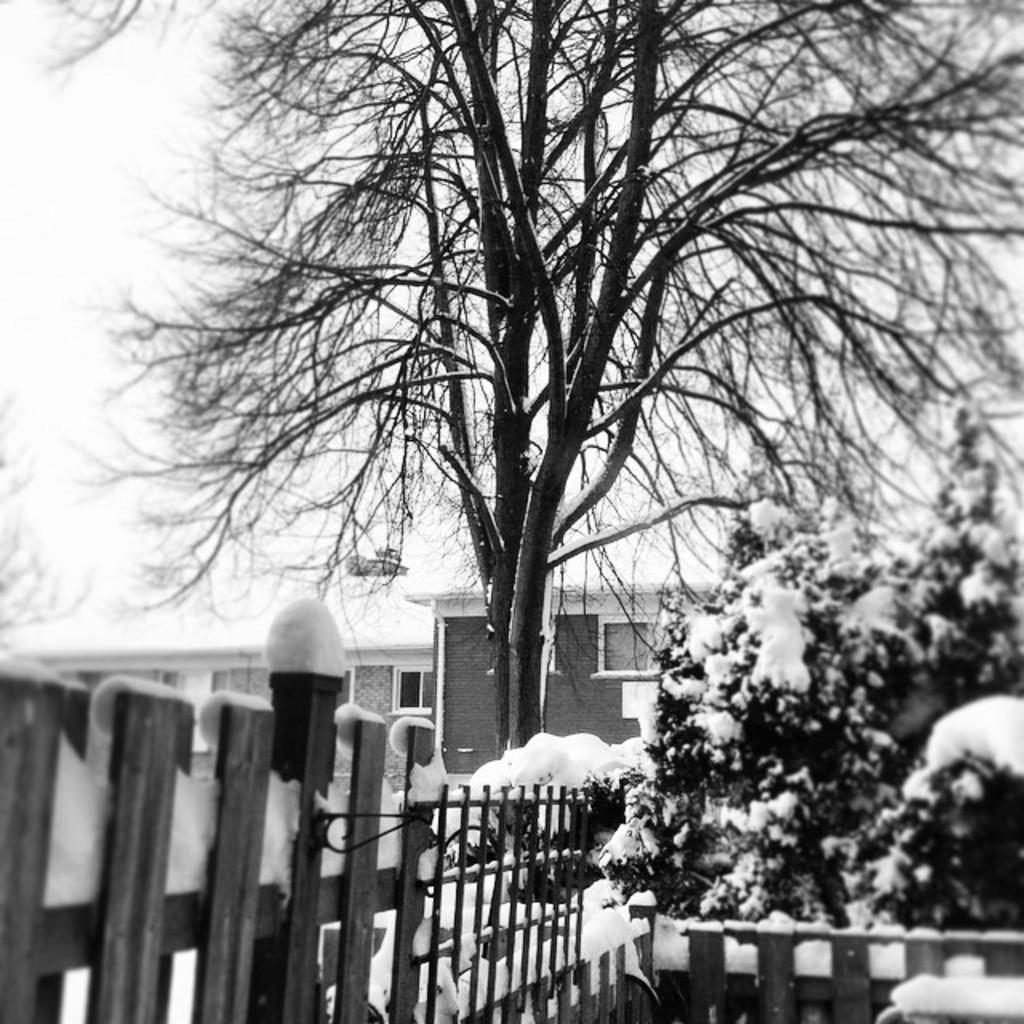Describe this image in one or two sentences. In front of the image there is a wooden fence. There is snow on the trees. In the background of the image there are buildings. At the top of the image there is sky. 